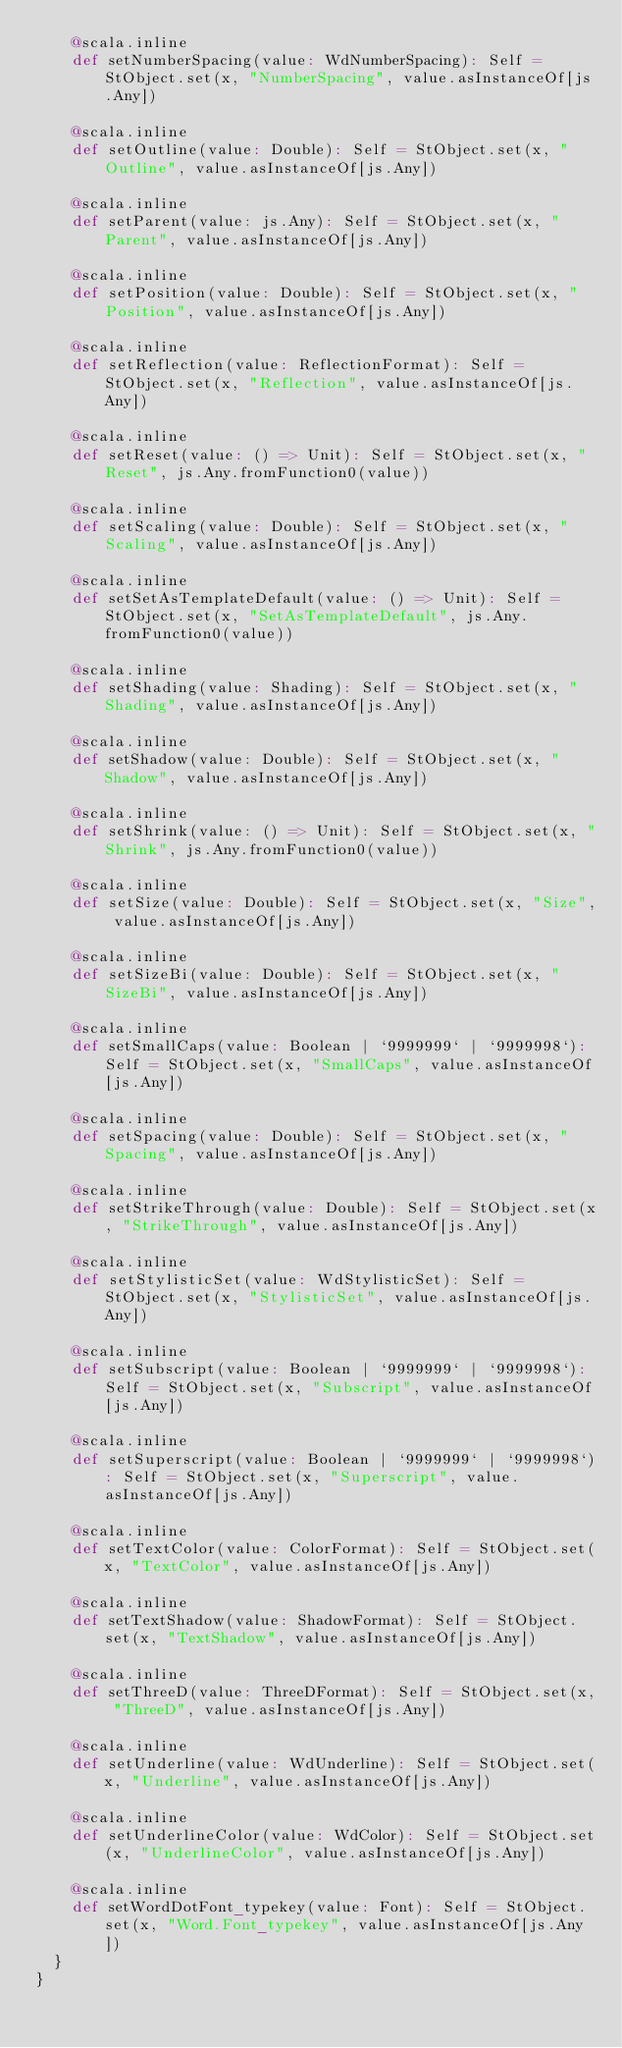<code> <loc_0><loc_0><loc_500><loc_500><_Scala_>    @scala.inline
    def setNumberSpacing(value: WdNumberSpacing): Self = StObject.set(x, "NumberSpacing", value.asInstanceOf[js.Any])
    
    @scala.inline
    def setOutline(value: Double): Self = StObject.set(x, "Outline", value.asInstanceOf[js.Any])
    
    @scala.inline
    def setParent(value: js.Any): Self = StObject.set(x, "Parent", value.asInstanceOf[js.Any])
    
    @scala.inline
    def setPosition(value: Double): Self = StObject.set(x, "Position", value.asInstanceOf[js.Any])
    
    @scala.inline
    def setReflection(value: ReflectionFormat): Self = StObject.set(x, "Reflection", value.asInstanceOf[js.Any])
    
    @scala.inline
    def setReset(value: () => Unit): Self = StObject.set(x, "Reset", js.Any.fromFunction0(value))
    
    @scala.inline
    def setScaling(value: Double): Self = StObject.set(x, "Scaling", value.asInstanceOf[js.Any])
    
    @scala.inline
    def setSetAsTemplateDefault(value: () => Unit): Self = StObject.set(x, "SetAsTemplateDefault", js.Any.fromFunction0(value))
    
    @scala.inline
    def setShading(value: Shading): Self = StObject.set(x, "Shading", value.asInstanceOf[js.Any])
    
    @scala.inline
    def setShadow(value: Double): Self = StObject.set(x, "Shadow", value.asInstanceOf[js.Any])
    
    @scala.inline
    def setShrink(value: () => Unit): Self = StObject.set(x, "Shrink", js.Any.fromFunction0(value))
    
    @scala.inline
    def setSize(value: Double): Self = StObject.set(x, "Size", value.asInstanceOf[js.Any])
    
    @scala.inline
    def setSizeBi(value: Double): Self = StObject.set(x, "SizeBi", value.asInstanceOf[js.Any])
    
    @scala.inline
    def setSmallCaps(value: Boolean | `9999999` | `9999998`): Self = StObject.set(x, "SmallCaps", value.asInstanceOf[js.Any])
    
    @scala.inline
    def setSpacing(value: Double): Self = StObject.set(x, "Spacing", value.asInstanceOf[js.Any])
    
    @scala.inline
    def setStrikeThrough(value: Double): Self = StObject.set(x, "StrikeThrough", value.asInstanceOf[js.Any])
    
    @scala.inline
    def setStylisticSet(value: WdStylisticSet): Self = StObject.set(x, "StylisticSet", value.asInstanceOf[js.Any])
    
    @scala.inline
    def setSubscript(value: Boolean | `9999999` | `9999998`): Self = StObject.set(x, "Subscript", value.asInstanceOf[js.Any])
    
    @scala.inline
    def setSuperscript(value: Boolean | `9999999` | `9999998`): Self = StObject.set(x, "Superscript", value.asInstanceOf[js.Any])
    
    @scala.inline
    def setTextColor(value: ColorFormat): Self = StObject.set(x, "TextColor", value.asInstanceOf[js.Any])
    
    @scala.inline
    def setTextShadow(value: ShadowFormat): Self = StObject.set(x, "TextShadow", value.asInstanceOf[js.Any])
    
    @scala.inline
    def setThreeD(value: ThreeDFormat): Self = StObject.set(x, "ThreeD", value.asInstanceOf[js.Any])
    
    @scala.inline
    def setUnderline(value: WdUnderline): Self = StObject.set(x, "Underline", value.asInstanceOf[js.Any])
    
    @scala.inline
    def setUnderlineColor(value: WdColor): Self = StObject.set(x, "UnderlineColor", value.asInstanceOf[js.Any])
    
    @scala.inline
    def setWordDotFont_typekey(value: Font): Self = StObject.set(x, "Word.Font_typekey", value.asInstanceOf[js.Any])
  }
}
</code> 